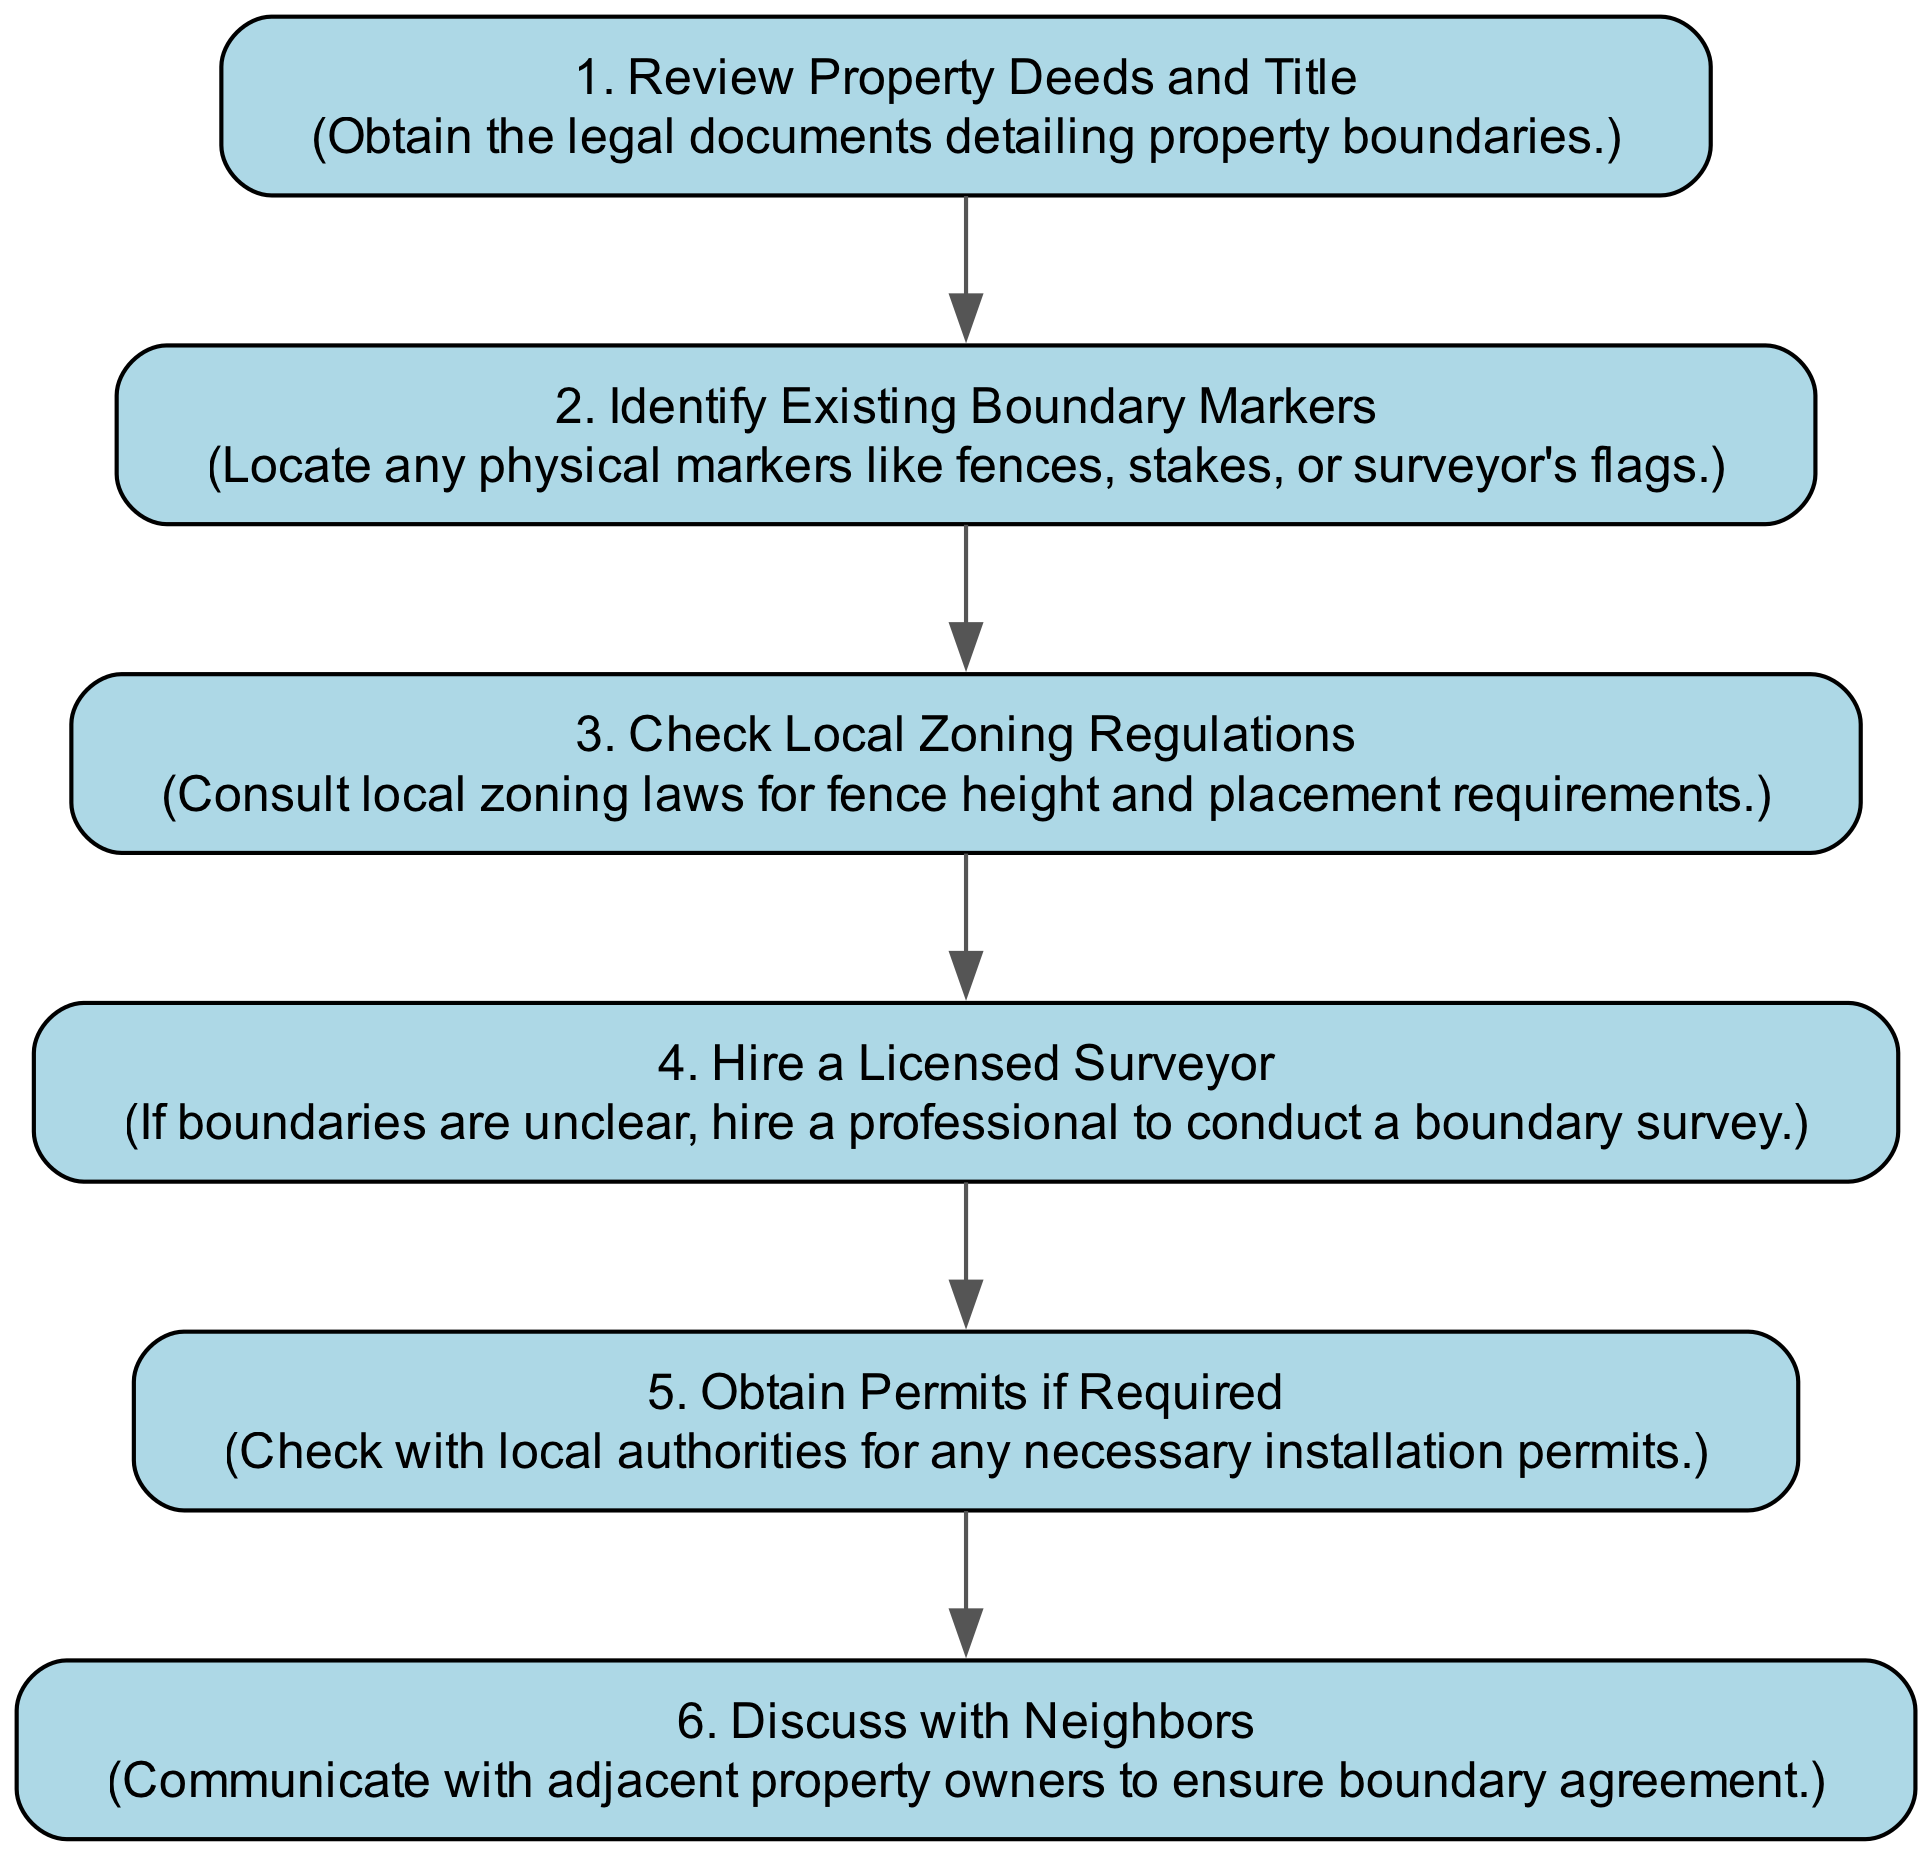What is the first step in assessing property lines? The flow chart indicates that the first step is to "Review Property Deeds and Title," which involves obtaining legal documents detailing property boundaries.
Answer: Review Property Deeds and Title How many steps are included in the diagram? The diagram includes a total of six steps, as indicated by the number of nodes present in the flow chart.
Answer: Six What is the action associated with hiring a licensed surveyor? The action mentioned for "Hire a Licensed Surveyor" is to "If boundaries are unclear, hire a professional to conduct a boundary survey."
Answer: If boundaries are unclear, hire a professional to conduct a boundary survey What step follows checking local zoning regulations? After "Check Local Zoning Regulations," the next step is to "Hire a Licensed Surveyor," as seen by the flow of the diagram.
Answer: Hire a Licensed Surveyor Which step emphasizes communication with adjacent property owners? The step that emphasizes communication with adjacent property owners is "Discuss with Neighbors," which encourages ensuring boundary agreement.
Answer: Discuss with Neighbors If boundaries are clear, what step is likely skipped? If boundaries are clear, the step "Hire a Licensed Surveyor" is likely skipped, as it is only necessary if boundaries are unclear.
Answer: Hire a Licensed Surveyor What action is recommended to ensure compliance before fence installation? The flow chart recommends "Obtain Permits if Required" to check with local authorities for any necessary installation permits.
Answer: Obtain Permits if Required What is the relationship between reviewing property deeds and discussing with neighbors? The relationship is that reviewing property deeds lays the groundwork for understanding boundaries, which is important before moving to discuss with neighbors about the boundaries.
Answer: Foundation for Discussion Which step addresses potential legal requirements before installation? The step that addresses potential legal requirements is "Obtain Permits if Required," which focuses on checking for necessary permits from local authorities.
Answer: Obtain Permits if Required 